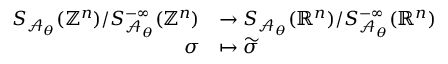<formula> <loc_0><loc_0><loc_500><loc_500>\begin{array} { r l } { S _ { \mathcal { A } _ { \theta } } ( \mathbb { Z } ^ { n } ) / S _ { \mathcal { A } _ { \theta } } ^ { - \infty } ( \mathbb { Z } ^ { n } ) } & { \to S _ { \mathcal { A } _ { \theta } } ( \mathbb { R } ^ { n } ) / S _ { \mathcal { A } _ { \theta } } ^ { - \infty } ( \mathbb { R } ^ { n } ) } \\ { \sigma } & { \mapsto \widetilde { \sigma } } \end{array}</formula> 